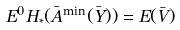<formula> <loc_0><loc_0><loc_500><loc_500>E ^ { 0 } H _ { * } ( \bar { A } ^ { \min } ( \bar { Y } ) ) = E ( \bar { V } )</formula> 